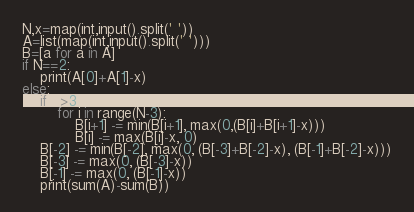<code> <loc_0><loc_0><loc_500><loc_500><_Python_>N,x=map(int,input().split(' '))
A=list(map(int,input().split(' ')))
B=[a for a in A]
if N==2:
	print(A[0]+A[1]-x)
else:
	if N>3:
		for i in range(N-3):
			B[i+1] -= min(B[i+1], max(0,(B[i]+B[i+1]-x)))
			B[i] -= max(B[i]-x, 0)
	B[-2] -= min(B[-2], max(0, (B[-3]+B[-2]-x), (B[-1]+B[-2]-x)))
	B[-3] -= max(0, (B[-3]-x))
	B[-1] -= max(0, (B[-1]-x))
	print(sum(A)-sum(B))</code> 